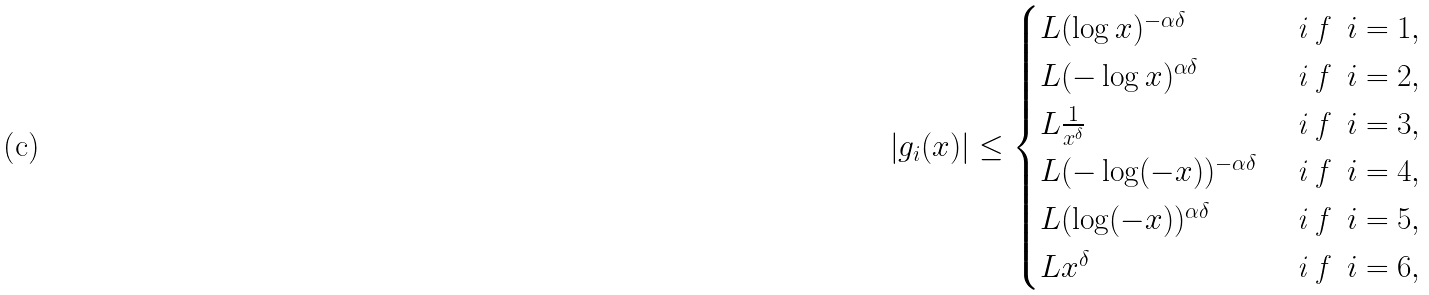Convert formula to latex. <formula><loc_0><loc_0><loc_500><loc_500>\left | g _ { i } ( x ) \right | & \leq \begin{cases} L ( \log x ) ^ { - \alpha \delta } & \emph { i f } \ i = 1 , \\ L ( - \log x ) ^ { \alpha \delta } & \emph { i f } \ i = 2 , \\ L \frac { 1 } { x ^ { \delta } } & \emph { i f } \ i = 3 , \\ L ( - \log ( - x ) ) ^ { - \alpha \delta } & \emph { i f } \ i = 4 , \\ L ( \log ( - x ) ) ^ { \alpha \delta } & \emph { i f } \ i = 5 , \\ L x ^ { \delta } & \emph { i f } \ i = 6 , \end{cases}</formula> 